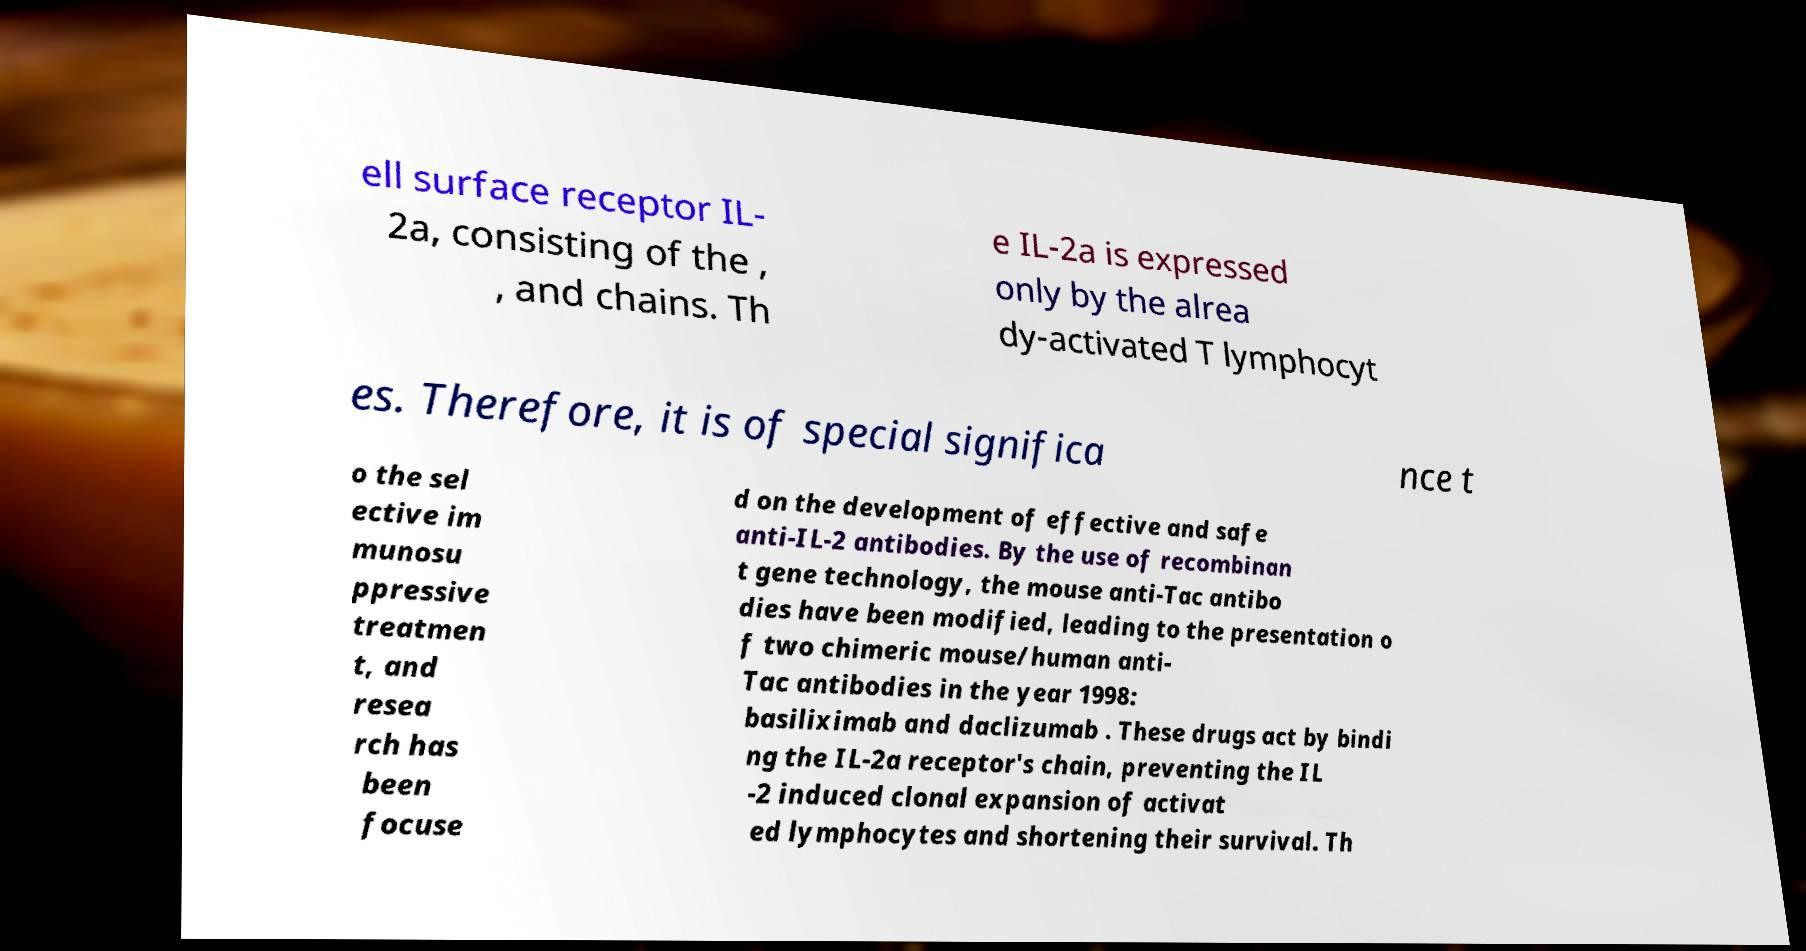Please read and relay the text visible in this image. What does it say? ell surface receptor IL- 2a, consisting of the , , and chains. Th e IL-2a is expressed only by the alrea dy-activated T lymphocyt es. Therefore, it is of special significa nce t o the sel ective im munosu ppressive treatmen t, and resea rch has been focuse d on the development of effective and safe anti-IL-2 antibodies. By the use of recombinan t gene technology, the mouse anti-Tac antibo dies have been modified, leading to the presentation o f two chimeric mouse/human anti- Tac antibodies in the year 1998: basiliximab and daclizumab . These drugs act by bindi ng the IL-2a receptor's chain, preventing the IL -2 induced clonal expansion of activat ed lymphocytes and shortening their survival. Th 